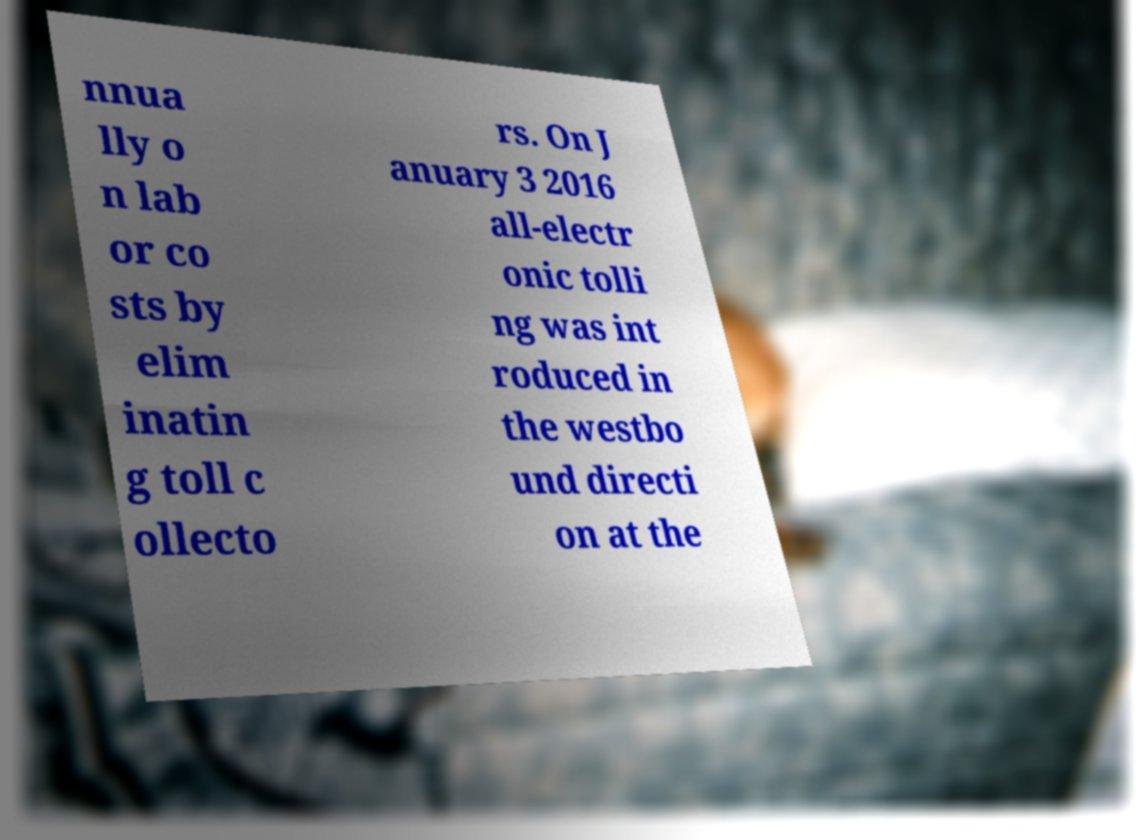Can you accurately transcribe the text from the provided image for me? nnua lly o n lab or co sts by elim inatin g toll c ollecto rs. On J anuary 3 2016 all-electr onic tolli ng was int roduced in the westbo und directi on at the 